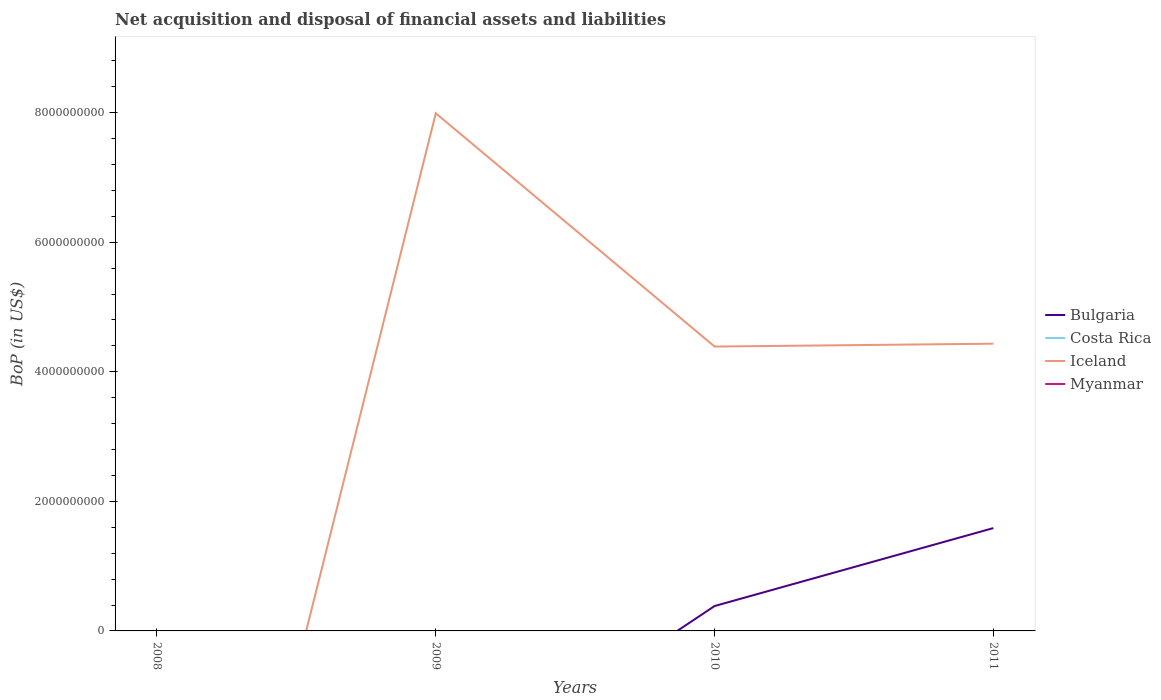Does the line corresponding to Iceland intersect with the line corresponding to Myanmar?
Offer a terse response. Yes. Is the number of lines equal to the number of legend labels?
Keep it short and to the point. No. Across all years, what is the maximum Balance of Payments in Myanmar?
Provide a short and direct response. 0. What is the total Balance of Payments in Bulgaria in the graph?
Provide a succinct answer. -1.20e+09. What is the difference between the highest and the second highest Balance of Payments in Iceland?
Offer a terse response. 7.99e+09. Is the Balance of Payments in Costa Rica strictly greater than the Balance of Payments in Myanmar over the years?
Ensure brevity in your answer.  Yes. How many years are there in the graph?
Your answer should be compact. 4. Are the values on the major ticks of Y-axis written in scientific E-notation?
Provide a succinct answer. No. How many legend labels are there?
Provide a short and direct response. 4. How are the legend labels stacked?
Your answer should be very brief. Vertical. What is the title of the graph?
Make the answer very short. Net acquisition and disposal of financial assets and liabilities. What is the label or title of the Y-axis?
Offer a very short reply. BoP (in US$). What is the BoP (in US$) in Costa Rica in 2008?
Offer a very short reply. 0. What is the BoP (in US$) in Costa Rica in 2009?
Keep it short and to the point. 0. What is the BoP (in US$) of Iceland in 2009?
Offer a terse response. 7.99e+09. What is the BoP (in US$) of Myanmar in 2009?
Keep it short and to the point. 0. What is the BoP (in US$) in Bulgaria in 2010?
Give a very brief answer. 3.84e+08. What is the BoP (in US$) in Costa Rica in 2010?
Your answer should be compact. 0. What is the BoP (in US$) in Iceland in 2010?
Ensure brevity in your answer.  4.39e+09. What is the BoP (in US$) in Myanmar in 2010?
Offer a very short reply. 0. What is the BoP (in US$) of Bulgaria in 2011?
Your answer should be very brief. 1.59e+09. What is the BoP (in US$) of Iceland in 2011?
Offer a very short reply. 4.43e+09. What is the BoP (in US$) in Myanmar in 2011?
Offer a very short reply. 0. Across all years, what is the maximum BoP (in US$) in Bulgaria?
Your answer should be very brief. 1.59e+09. Across all years, what is the maximum BoP (in US$) of Iceland?
Your answer should be compact. 7.99e+09. What is the total BoP (in US$) of Bulgaria in the graph?
Your response must be concise. 1.97e+09. What is the total BoP (in US$) in Costa Rica in the graph?
Offer a terse response. 0. What is the total BoP (in US$) of Iceland in the graph?
Provide a succinct answer. 1.68e+1. What is the difference between the BoP (in US$) in Iceland in 2009 and that in 2010?
Your answer should be compact. 3.60e+09. What is the difference between the BoP (in US$) in Iceland in 2009 and that in 2011?
Keep it short and to the point. 3.56e+09. What is the difference between the BoP (in US$) in Bulgaria in 2010 and that in 2011?
Provide a succinct answer. -1.20e+09. What is the difference between the BoP (in US$) of Iceland in 2010 and that in 2011?
Make the answer very short. -4.42e+07. What is the difference between the BoP (in US$) in Bulgaria in 2010 and the BoP (in US$) in Iceland in 2011?
Your response must be concise. -4.05e+09. What is the average BoP (in US$) of Bulgaria per year?
Keep it short and to the point. 4.93e+08. What is the average BoP (in US$) of Iceland per year?
Provide a succinct answer. 4.20e+09. In the year 2010, what is the difference between the BoP (in US$) of Bulgaria and BoP (in US$) of Iceland?
Keep it short and to the point. -4.00e+09. In the year 2011, what is the difference between the BoP (in US$) in Bulgaria and BoP (in US$) in Iceland?
Keep it short and to the point. -2.85e+09. What is the ratio of the BoP (in US$) in Iceland in 2009 to that in 2010?
Offer a terse response. 1.82. What is the ratio of the BoP (in US$) of Iceland in 2009 to that in 2011?
Ensure brevity in your answer.  1.8. What is the ratio of the BoP (in US$) of Bulgaria in 2010 to that in 2011?
Provide a succinct answer. 0.24. What is the difference between the highest and the second highest BoP (in US$) in Iceland?
Provide a short and direct response. 3.56e+09. What is the difference between the highest and the lowest BoP (in US$) in Bulgaria?
Your answer should be compact. 1.59e+09. What is the difference between the highest and the lowest BoP (in US$) of Iceland?
Give a very brief answer. 7.99e+09. 